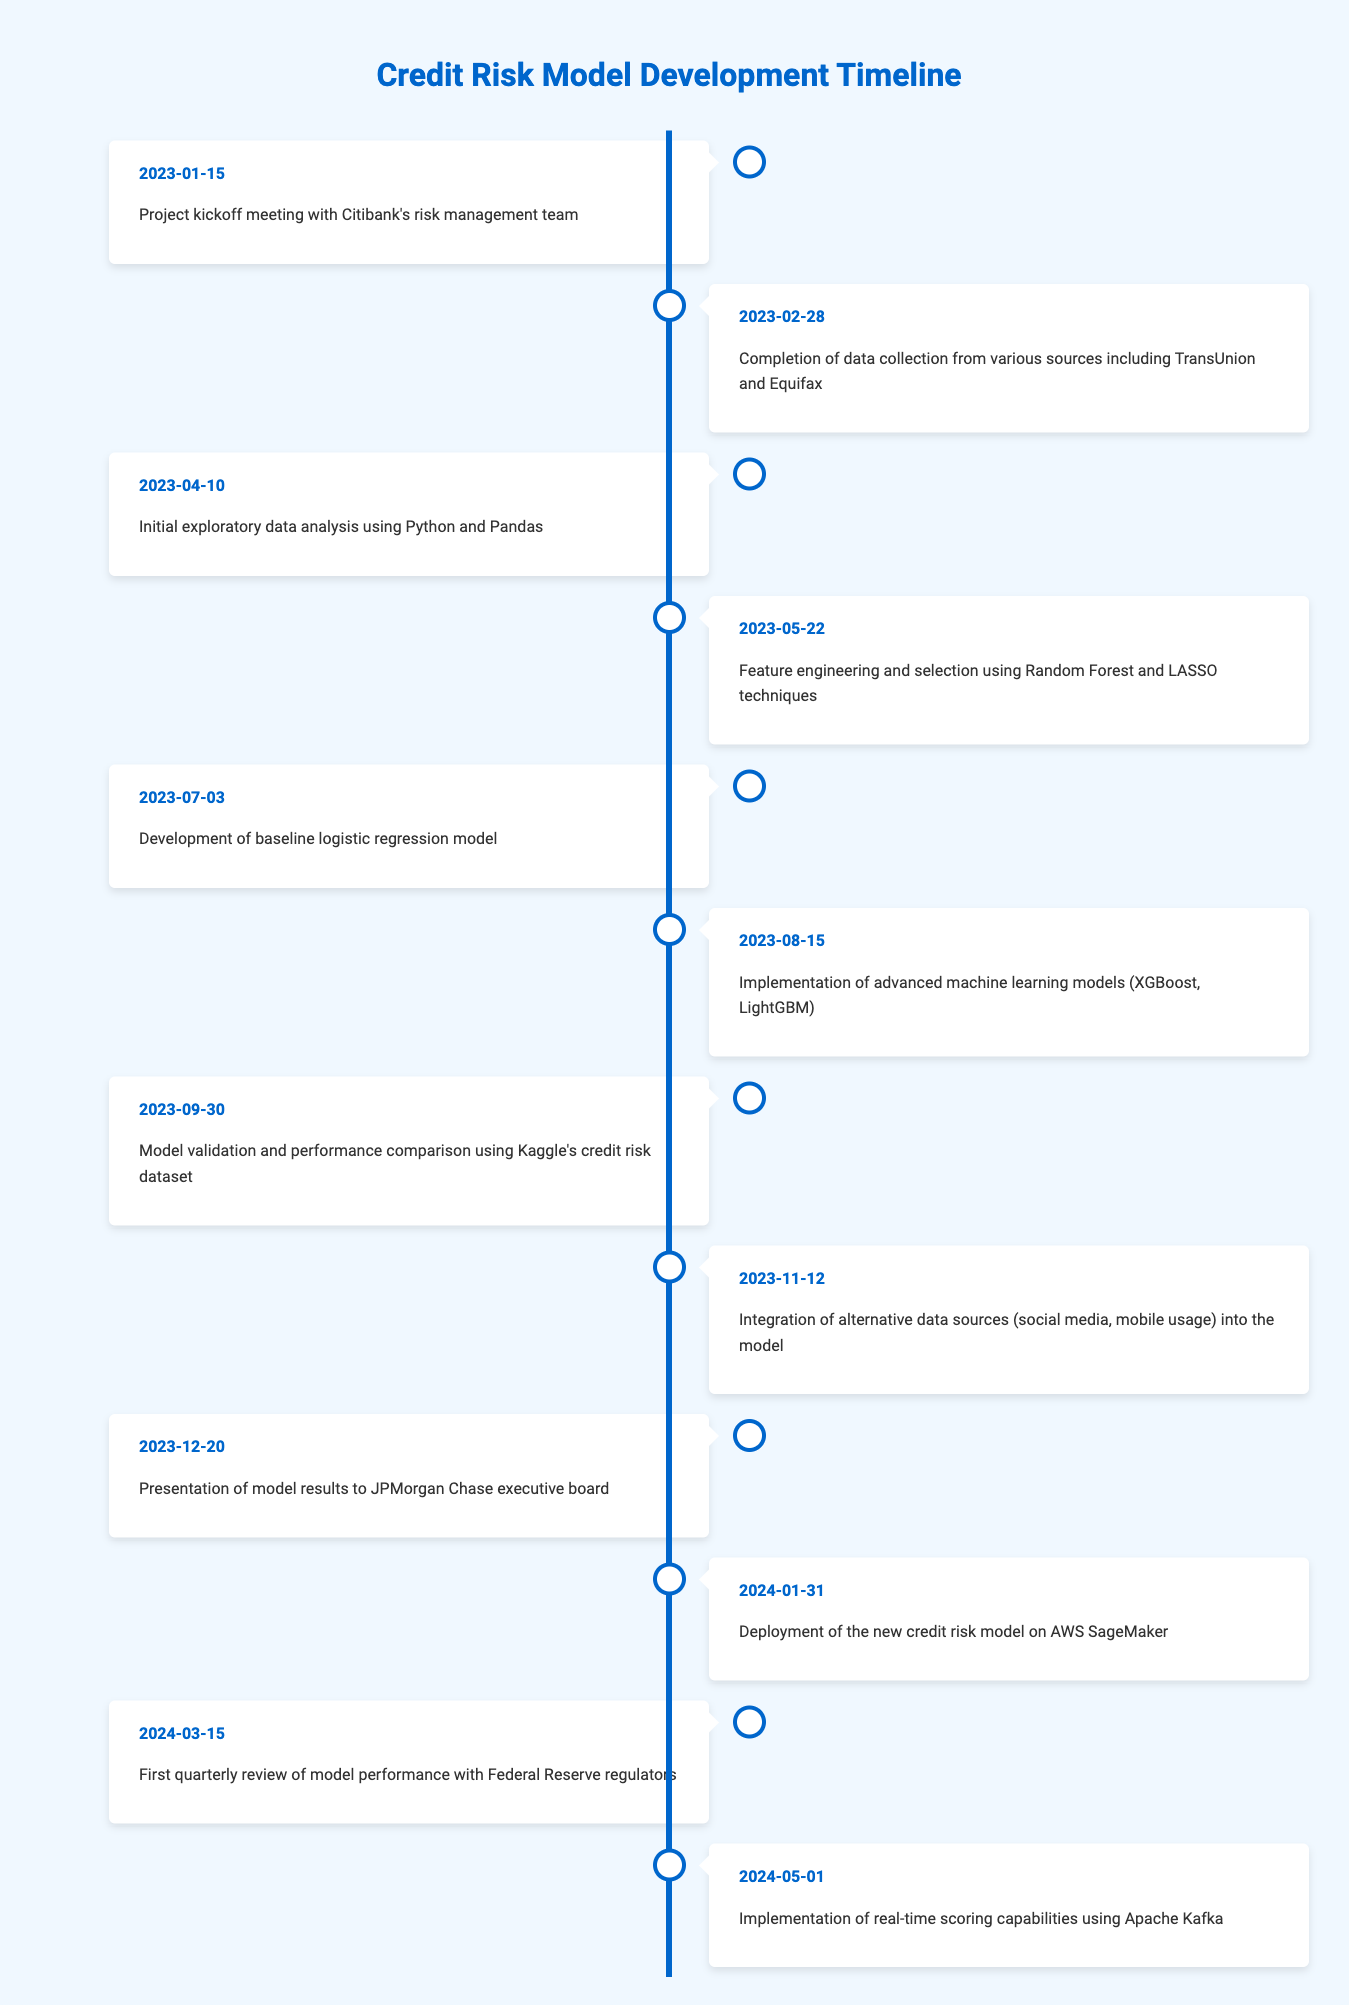What is the date of the project kickoff meeting? The table shows the milestone events along with their corresponding dates. The project kickoff meeting is listed as the first event, which occurred on January 15, 2023.
Answer: January 15, 2023 What event took place on February 28, 2023? Looking at the table under the date February 28, 2023, the event that occurred is the completion of data collection from various sources, including TransUnion and Equifax.
Answer: Completion of data collection from various sources including TransUnion and Equifax Which model was developed on July 3, 2023? By checking the date July 3, 2023 on the timeline, it indicates that a baseline logistic regression model was developed on that date.
Answer: Development of baseline logistic regression model How many months passed between the model validation on September 30, 2023, and the deployment on January 31, 2024? First, identify the two dates: September 30, 2023 to January 31, 2024. Count the months: October, November, December, and January (end) gives a total of 4 months.
Answer: 4 months Was the integration of alternative data sources completed before the presentation to the executive board? The integration of alternative data sources took place on November 12, 2023, which is before the presentation to the JPMorgan Chase executive board on December 20, 2023. Therefore, the statement is true.
Answer: Yes Which event is the last step in the timeline before the first quarterly review? The last event listed before the first quarterly review on March 15, 2024, is the deployment of the new credit risk model on January 31, 2024. So, that means the deployment event is the one immediately preceding the review.
Answer: Deployment of the new credit risk model on AWS SageMaker How many days were there between the completion of data collection and the implementation of advanced machine learning models? The completion of data collection was on February 28, 2023, and the implementation of advanced machine learning models occurred on August 15, 2023. To find the difference, calculate the number of days from February 28 to August 15. This spans 5 months and 17 days. Converting the months to days: March (31), April (30), May (31), June (30), July (31) gives 31 + 30 + 31 + 30 + 31 = 153 days, plus 17 more gives 170 days total.
Answer: 170 days What was the first event related to data analysis in the timeline? The timeline lists events in chronological order. The first event related to data analysis is the initial exploratory data analysis using Python and Pandas, which happened on April 10, 2023.
Answer: Initial exploratory data analysis using Python and Pandas How many different machine learning models were implemented before the first quarterly review? Looking at the timeline, two advanced machine learning models were implemented: XGBoost and LightGBM on August 15, 2023. Since no other models were mentioned prior to the review, the answer remains 2.
Answer: 2 